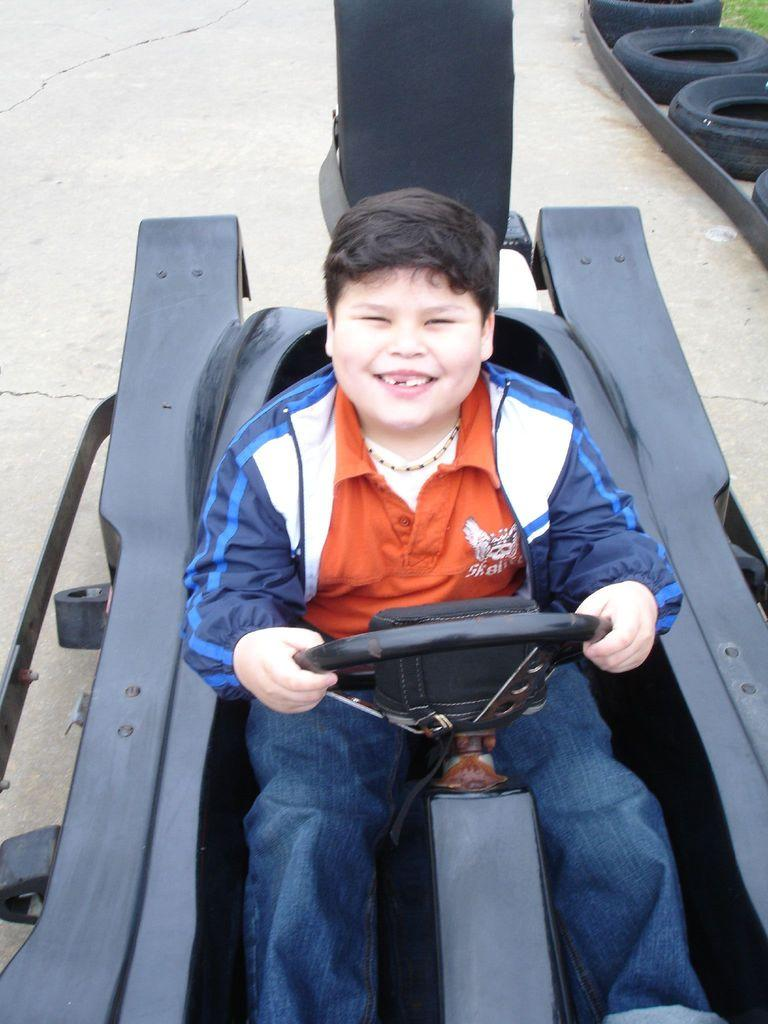Who is the main subject in the image? There is a boy in the image. What is the boy doing in the image? The boy is riding a vehicle. What is the boy wearing in the image? The boy is wearing a red t-shirt and blue jeans. What is the boy's facial expression in the image? The boy is smiling in the image. What type of noise can be heard coming from the boy's toothbrush in the image? There is no toothbrush present in the image, so it is not possible to determine what noise, if any, might be heard. 